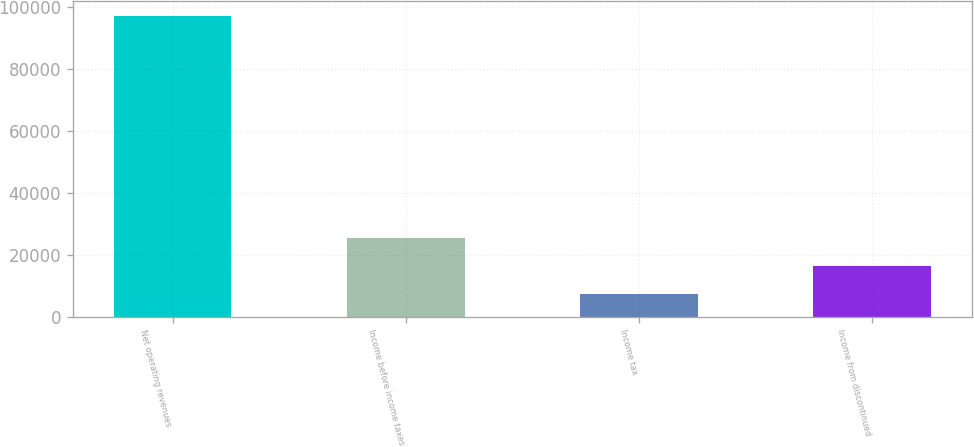<chart> <loc_0><loc_0><loc_500><loc_500><bar_chart><fcel>Net operating revenues<fcel>Income before income taxes<fcel>Income tax<fcel>Income from discontinued<nl><fcel>97139<fcel>25269.4<fcel>7302<fcel>16285.7<nl></chart> 